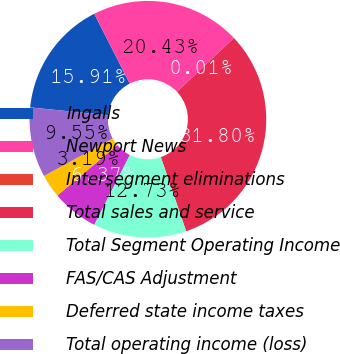Convert chart to OTSL. <chart><loc_0><loc_0><loc_500><loc_500><pie_chart><fcel>Ingalls<fcel>Newport News<fcel>Intersegment eliminations<fcel>Total sales and service<fcel>Total Segment Operating Income<fcel>FAS/CAS Adjustment<fcel>Deferred state income taxes<fcel>Total operating income (loss)<nl><fcel>15.91%<fcel>20.43%<fcel>0.01%<fcel>31.8%<fcel>12.73%<fcel>6.37%<fcel>3.19%<fcel>9.55%<nl></chart> 